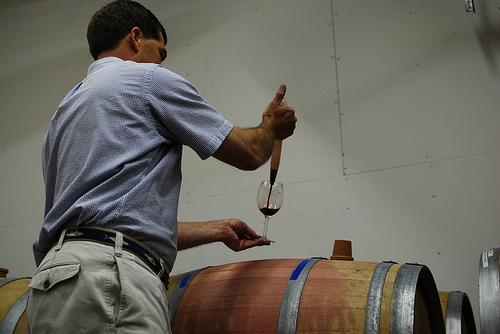Summarize the man's appearance and the object he is interacting with. A man in a light blue shirt, khaki pants, and a black belt is pouring wine into a glass with a thick stem. Describe the main activity taking place and any notable characteristics of the man involved in the image. A man wearing a collared blue shirt and pants with a back pocket is preparing to test the wine by pouring it into a glass. Explain what the man is doing in the image and mention any relevant features or objects around him. A man with short dark hair is sampling red wine by pouring it into a transparent glass, standing in front of a stained wine barrel. What is the dominant setting in the image and describe any specific details about it. The dominant setting is a wine-making store, featuring a light brown wooden barrel with red stain and silver trim. Provide an overview of the scene, including the central figure and any noteworthy surroundings. A man in a short sleeve blue shirt and khaki pants is pouring red wine into a glass, standing near a wooden barrel with metal rings. Describe the main subject of the image and the specific action they are performing in detail. A man with short brown hair wearing a blue shirt and khaki pants is carefully pouring red wine from a bottle into a wine glass. Detail the appearance of the man and his actions in relation to a specific object in the image. A man with short black hair in a blue shirt and khaki pants is squeezing wine into a wine glass with red wine falling into it. Provide a brief description of the man in the image and his actions. A man wearing a blue shirt, khaki pants, and a patterned belt is pouring red wine into a wine glass. Mention the primary figure in the image, the activity they are engaged in, and any unique aspects of the setting. A man in a blue shirt, khaki pants, and a patterned belt is getting a sample of red wine in a wine-making store with plain white walls. Discuss what the man in the image is doing and any important features of the environment around him. A man wearing a patterned belt and khaki pants is pouring wine into a glass in front of a barrel with blue tag and metal rim. 